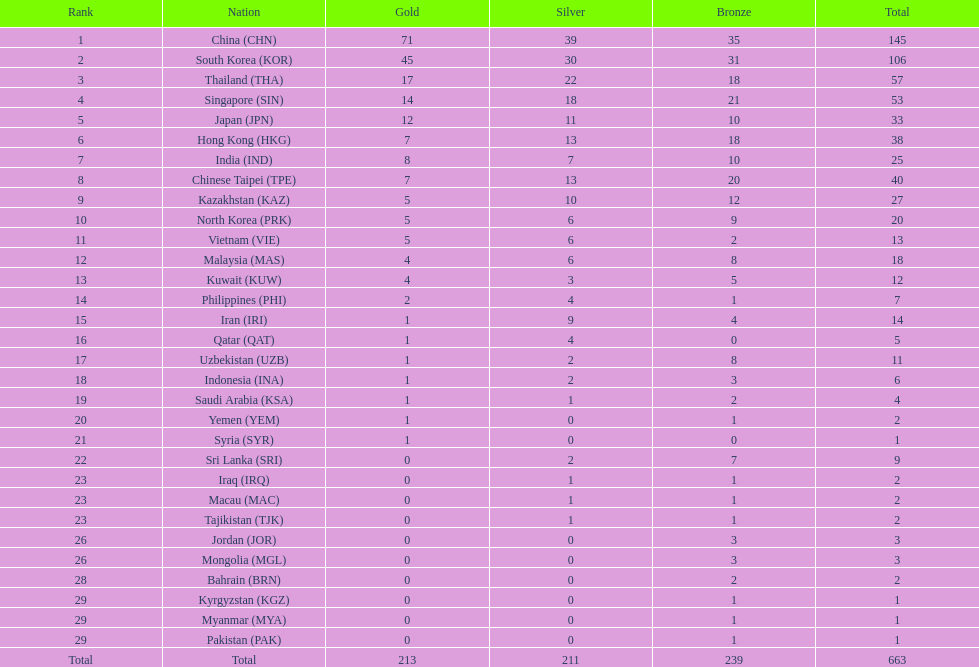What were the number of medals iran earned? 14. 